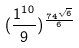Convert formula to latex. <formula><loc_0><loc_0><loc_500><loc_500>( \frac { 1 ^ { 1 0 } } { 9 } ) ^ { \frac { 7 4 ^ { \sqrt { 6 } } } { 6 } }</formula> 